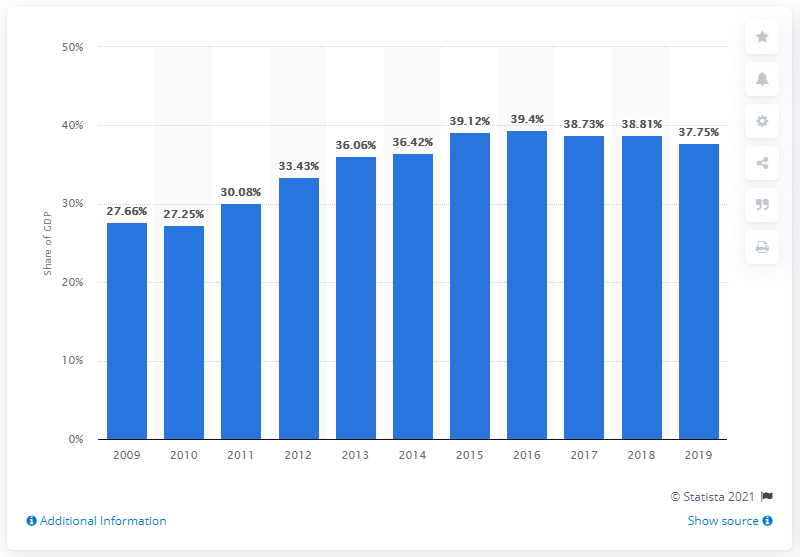Outline some significant characteristics in this image. In 2019, approximately 37.75% of Indonesia's GDP was comprised of domestic credit granted to the private sector. 